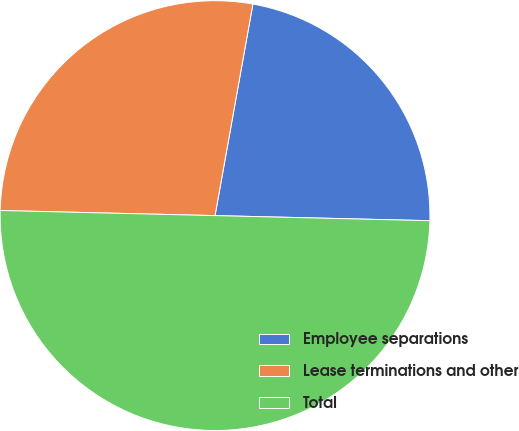<chart> <loc_0><loc_0><loc_500><loc_500><pie_chart><fcel>Employee separations<fcel>Lease terminations and other<fcel>Total<nl><fcel>22.56%<fcel>27.44%<fcel>50.0%<nl></chart> 